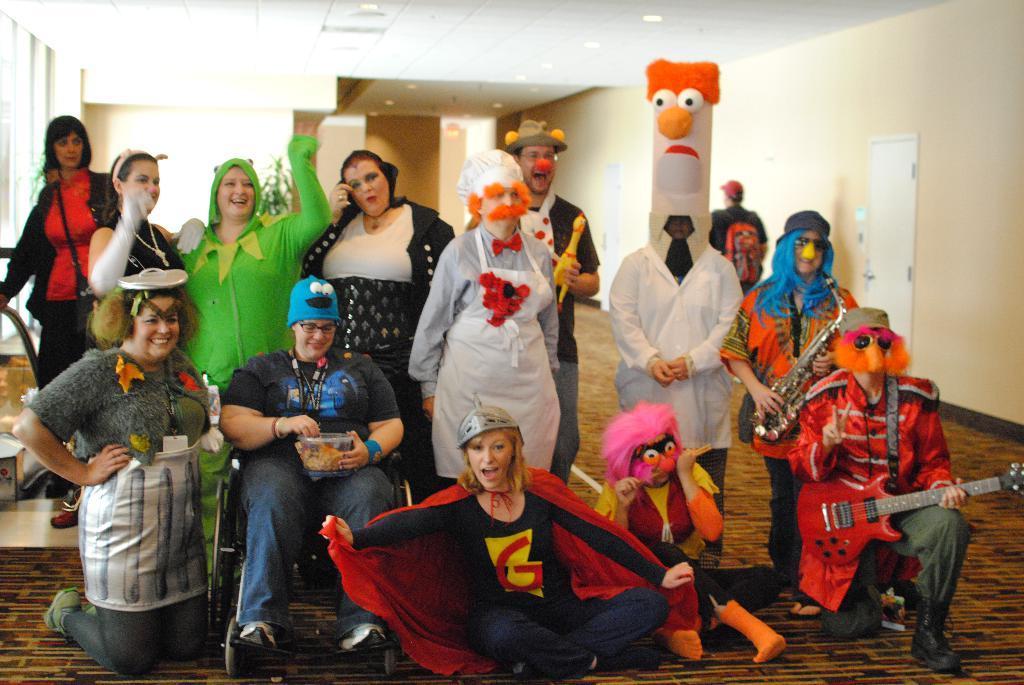In one or two sentences, can you explain what this image depicts? In this image there are few persons standing on the floor and they wore fancy dresses and among them a person is sitting on a wheelchair and holding a box with food item in it in her hands, few are holding musical instruments and few persons are standing on the knees and few persons are sitting on the floor. In the background there is a mascot, door, wall, lights on the ceiling and on the left side we can see glass door and plants. 